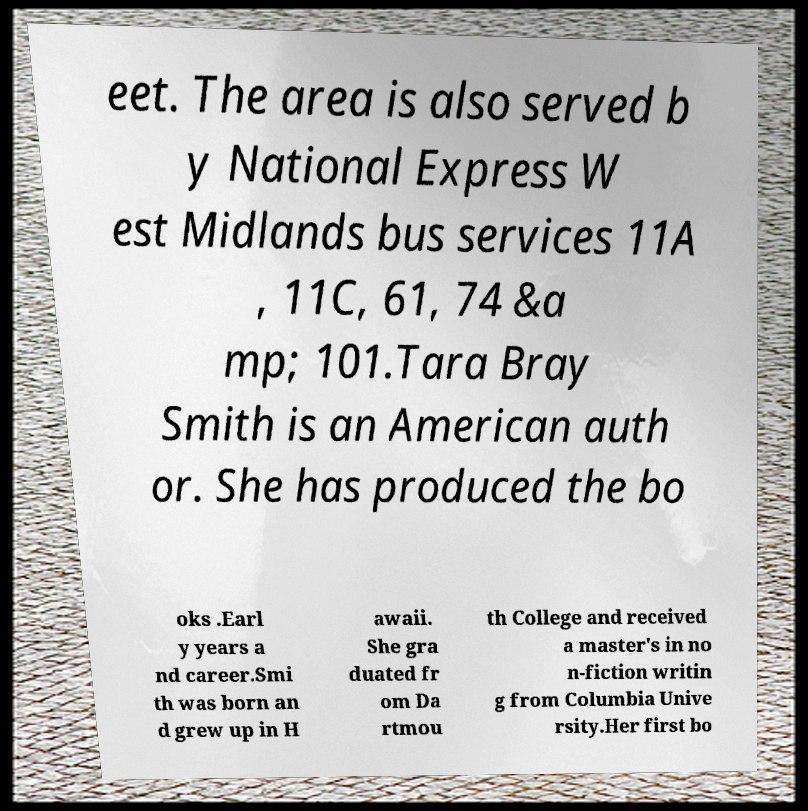Could you assist in decoding the text presented in this image and type it out clearly? eet. The area is also served b y National Express W est Midlands bus services 11A , 11C, 61, 74 &a mp; 101.Tara Bray Smith is an American auth or. She has produced the bo oks .Earl y years a nd career.Smi th was born an d grew up in H awaii. She gra duated fr om Da rtmou th College and received a master's in no n-fiction writin g from Columbia Unive rsity.Her first bo 